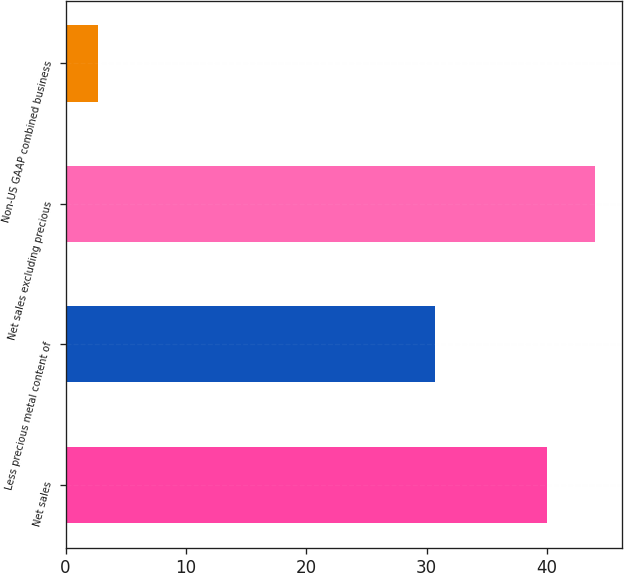<chart> <loc_0><loc_0><loc_500><loc_500><bar_chart><fcel>Net sales<fcel>Less precious metal content of<fcel>Net sales excluding precious<fcel>Non-US GAAP combined business<nl><fcel>40<fcel>30.7<fcel>43.99<fcel>2.7<nl></chart> 